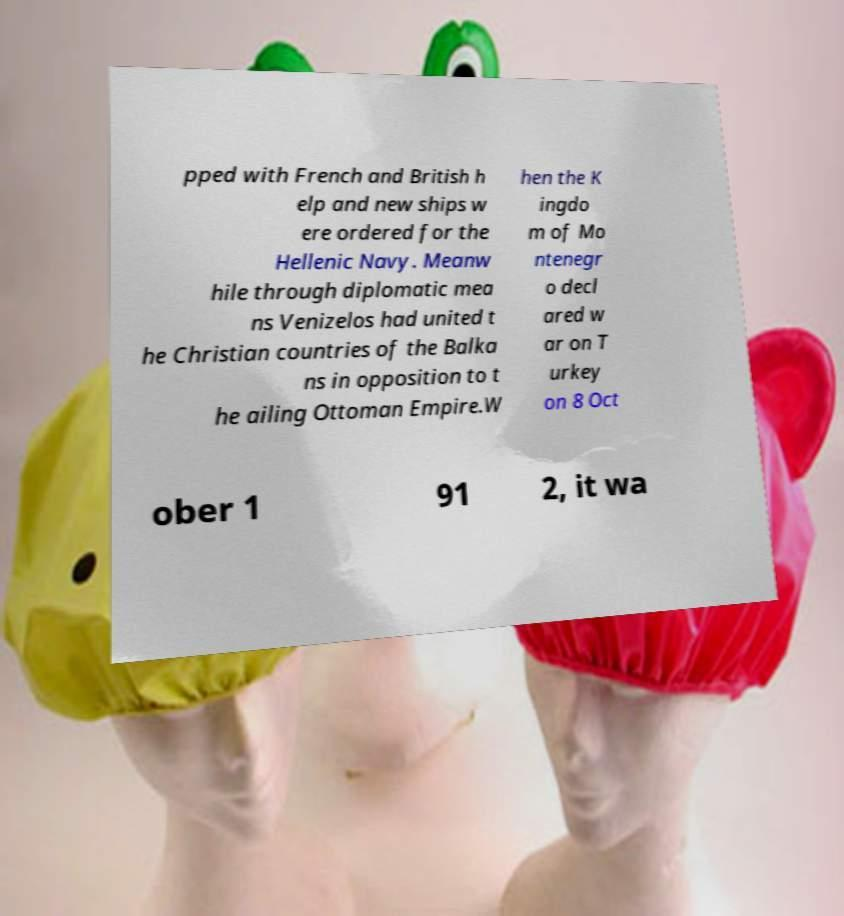For documentation purposes, I need the text within this image transcribed. Could you provide that? pped with French and British h elp and new ships w ere ordered for the Hellenic Navy. Meanw hile through diplomatic mea ns Venizelos had united t he Christian countries of the Balka ns in opposition to t he ailing Ottoman Empire.W hen the K ingdo m of Mo ntenegr o decl ared w ar on T urkey on 8 Oct ober 1 91 2, it wa 